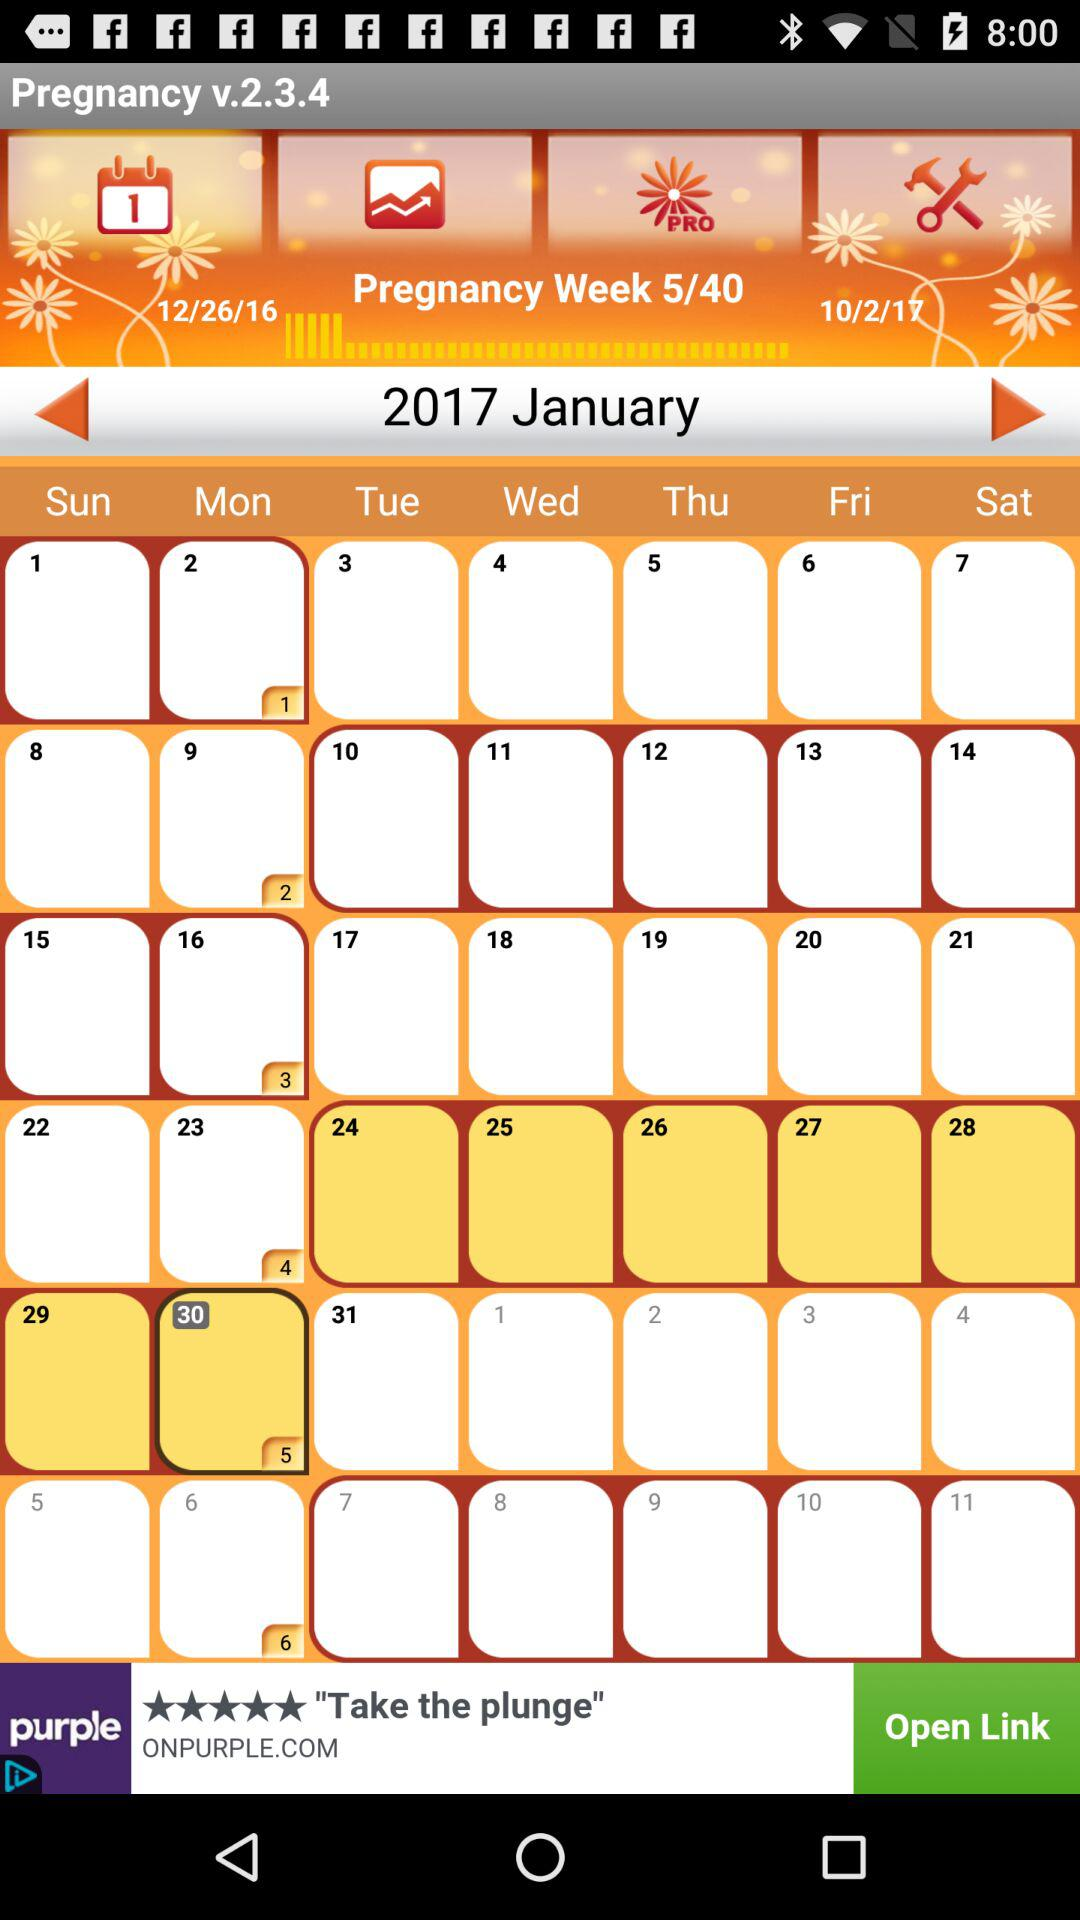What is the version number? The version number is v.2.3.4. 